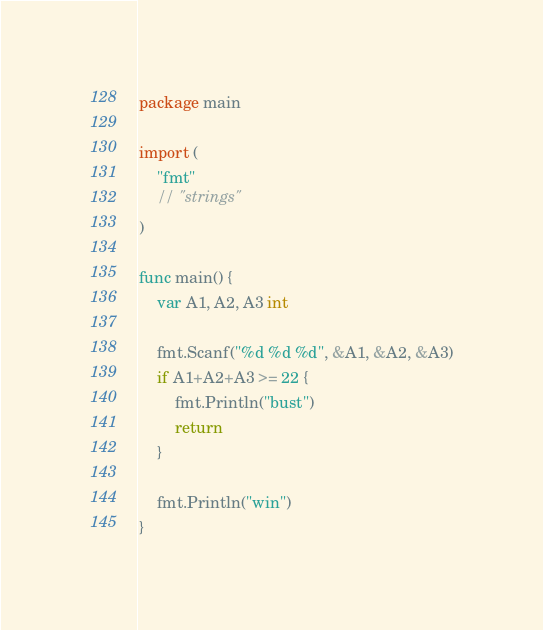<code> <loc_0><loc_0><loc_500><loc_500><_Go_>package main

import (
	"fmt"
	// "strings"
)

func main() {
	var A1, A2, A3 int

	fmt.Scanf("%d %d %d", &A1, &A2, &A3)
	if A1+A2+A3 >= 22 {
		fmt.Println("bust")
		return
	}

	fmt.Println("win")
}
</code> 